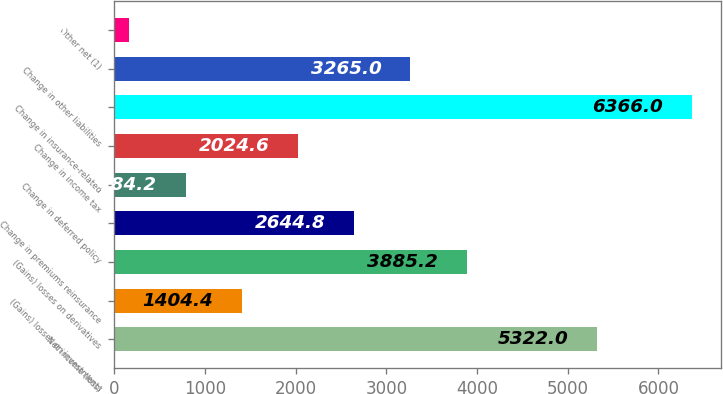<chart> <loc_0><loc_0><loc_500><loc_500><bar_chart><fcel>Net income (loss)<fcel>(Gains) losses on investments<fcel>(Gains) losses on derivatives<fcel>Change in premiums reinsurance<fcel>Change in deferred policy<fcel>Change in income tax<fcel>Change in insurance-related<fcel>Change in other liabilities<fcel>Other net (1)<nl><fcel>5322<fcel>1404.4<fcel>3885.2<fcel>2644.8<fcel>784.2<fcel>2024.6<fcel>6366<fcel>3265<fcel>164<nl></chart> 